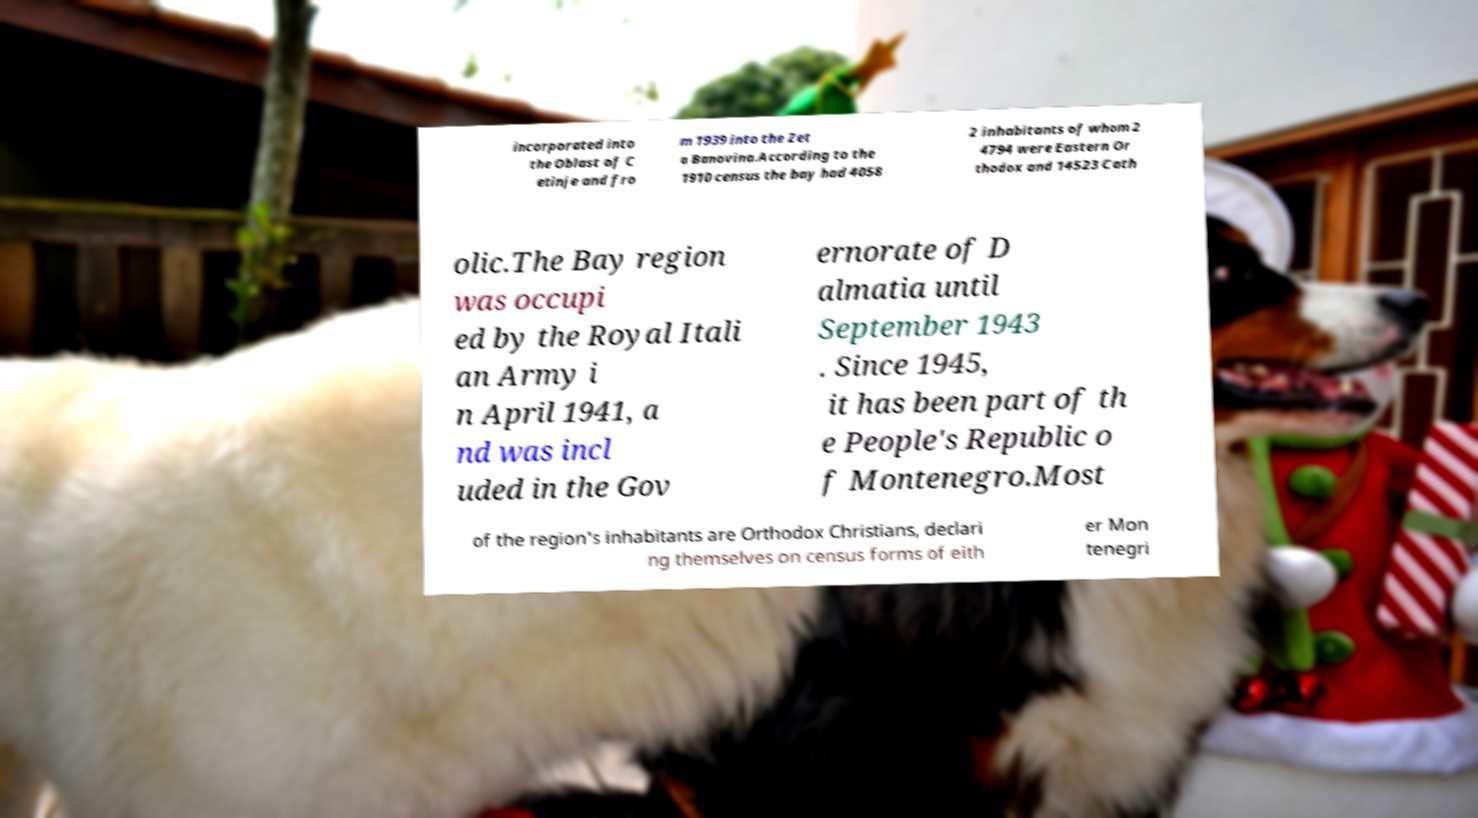I need the written content from this picture converted into text. Can you do that? incorporated into the Oblast of C etinje and fro m 1939 into the Zet a Banovina.According to the 1910 census the bay had 4058 2 inhabitants of whom 2 4794 were Eastern Or thodox and 14523 Cath olic.The Bay region was occupi ed by the Royal Itali an Army i n April 1941, a nd was incl uded in the Gov ernorate of D almatia until September 1943 . Since 1945, it has been part of th e People's Republic o f Montenegro.Most of the region's inhabitants are Orthodox Christians, declari ng themselves on census forms of eith er Mon tenegri 